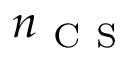Convert formula to latex. <formula><loc_0><loc_0><loc_500><loc_500>n _ { C S }</formula> 